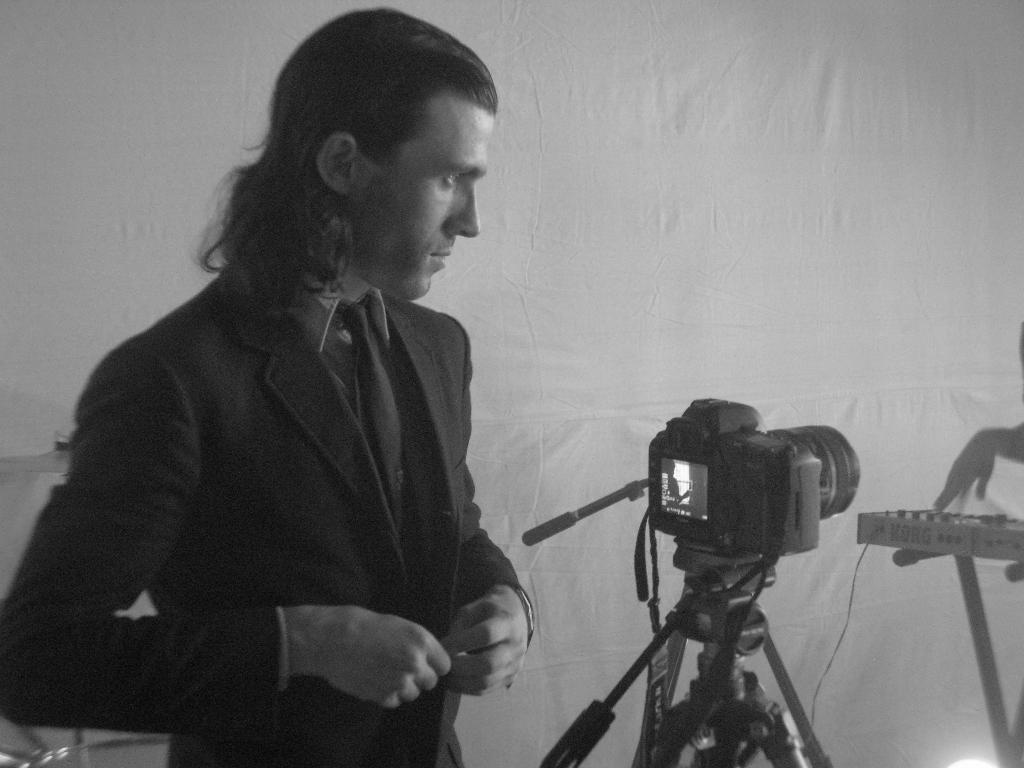What is the color scheme of the image? The image is black and white. What can be seen in the image besides the color scheme? There is a man standing in the image, a camera on a stand, a musical instrument, a hand of a person beside the musical instrument, and a curtain. What might the man be doing in the image? The man might be posing for a photograph, as there is a camera on a stand in the image. What is the musical instrument present in the image? The specific musical instrument is not mentioned, but it is present in the image along with a hand of a person beside it. Where is the shop located in the image? There is no shop present in the image. Can you see the sea in the image? The image does not depict any sea or water body. 